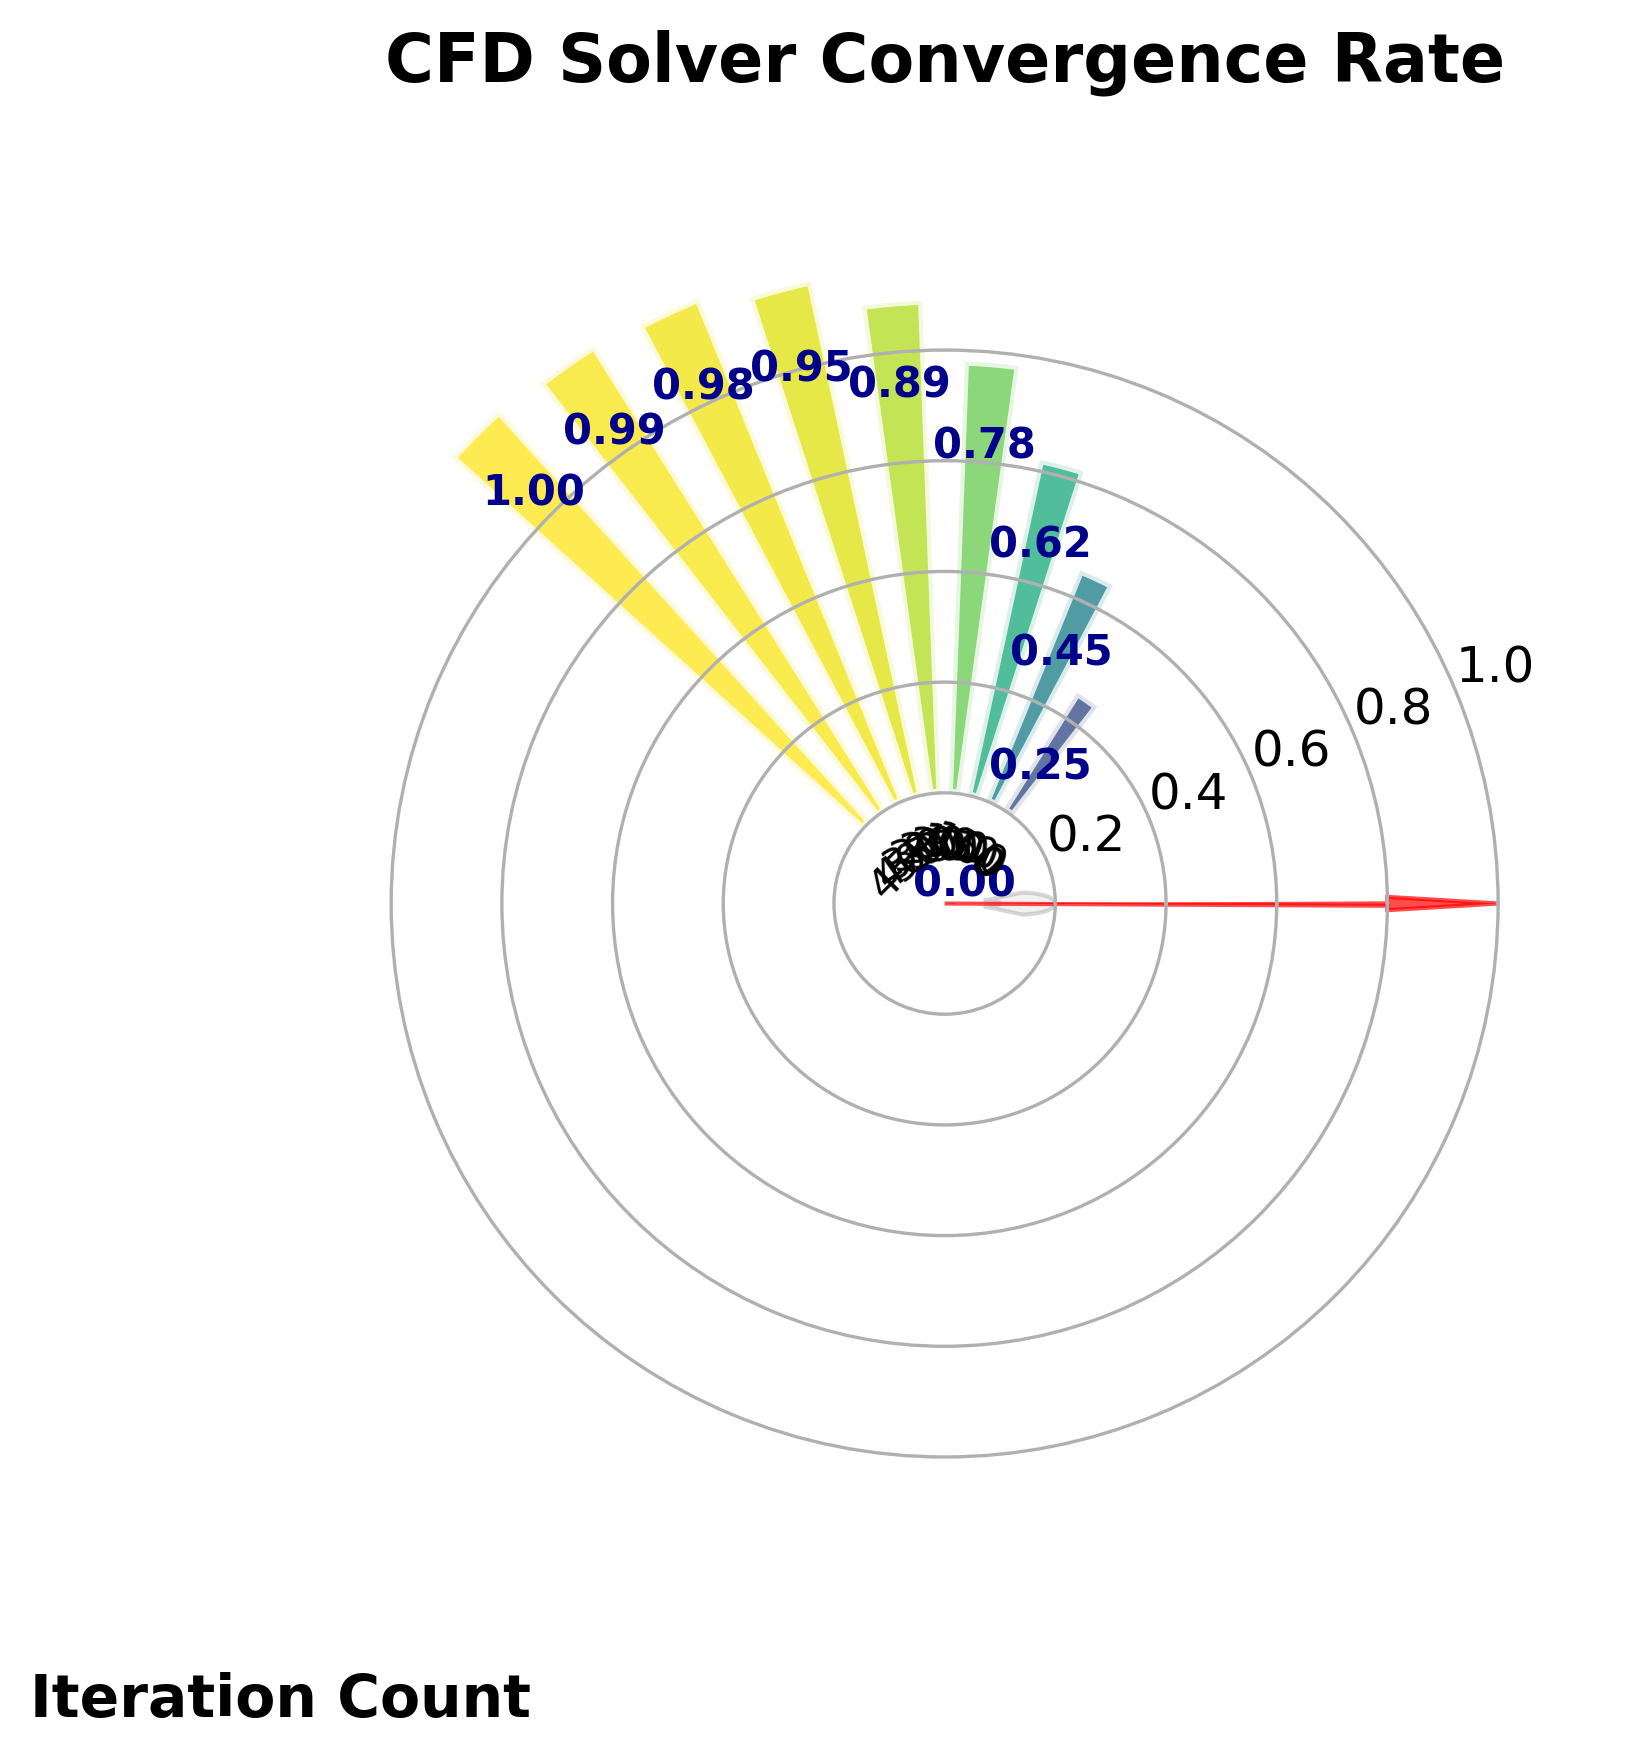How many iteration counts are represented on the gauge chart? The gauge chart shows iteration counts labeled at specific intervals marked on the chart. By looking at the text labels around the inner circle, we can count these intervals.
Answer: 10 What is the convergence rate at 200 iterations? Looking at the corresponding text label above the bar for 200 iterations, you can see the value indicated for the convergence rate at this iteration point.
Answer: 0.78 What is the overall trend of the convergence rate as the iteration count increases? Observing the bars on the gauge chart, you can see that the convergence rate increases as the iteration count goes up, starting from 0 and approaching 1.00 over 450 iterations.
Answer: Increasing trend Which iteration count marks the convergence rate achieving almost 1.00? By inspecting the text labels for each iteration along the gauge chart, you can identify that the convergence rate is nearly 1.00 at 400 iterations and finally reaches 1.00 at 450 iterations.
Answer: 450 How much did the convergence rate increase from 100 to 300 iterations? The convergence rate at 100 iterations is 0.45 and at 300 iterations is 0.95. Subtracting these values gives the increase. 0.95 - 0.45 = 0.50.
Answer: 0.50 At which iteration does the convergence rate exceed 0.50 for the first time? Starting from the beginning and moving rightward among the text labels, we see that the convergence rate first exceeds 0.50 between the labels for iteration 100 (0.45) and iteration 150 (0.62); thus, it first exceeds 0.50 at 150 iterations.
Answer: 150 Is the convergence rate change between the iterations 50-100 greater than or less than the change between the iterations 300-350? The change from 50 to 100 iterations is 0.45 - 0.25 = 0.20, and the change from 300 to 350 iterations is 0.98 - 0.95 = 0.03. Comparing these, 0.20 is greater than 0.03.
Answer: Greater What is the average convergence rate at intervals of 100 iterations? The convergence rates at intervals are 0.00, 0.25, 0.45, 0.62, 0.78, 0.89, 0.95, 0.98, 0.99, 1.00. Summing these values gives 0 + 0.25 + 0.45 + 0.62 + 0.78 + 0.89 + 0.95 + 0.98 + 0.99 + 1.00 = 6.91. There are 10 values, so the average is 6.91 / 10 = 0.691.
Answer: 0.691 